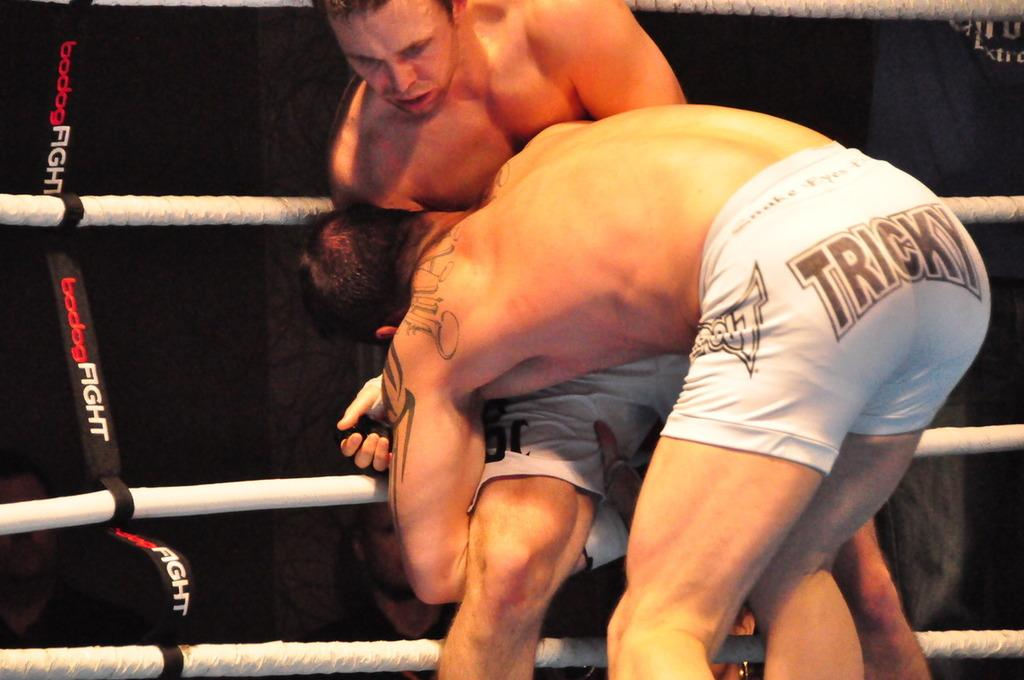<image>
Provide a brief description of the given image. Two MMA fighters, one wearing a white "tricky" shorts, are grappling for control against the ropes. 